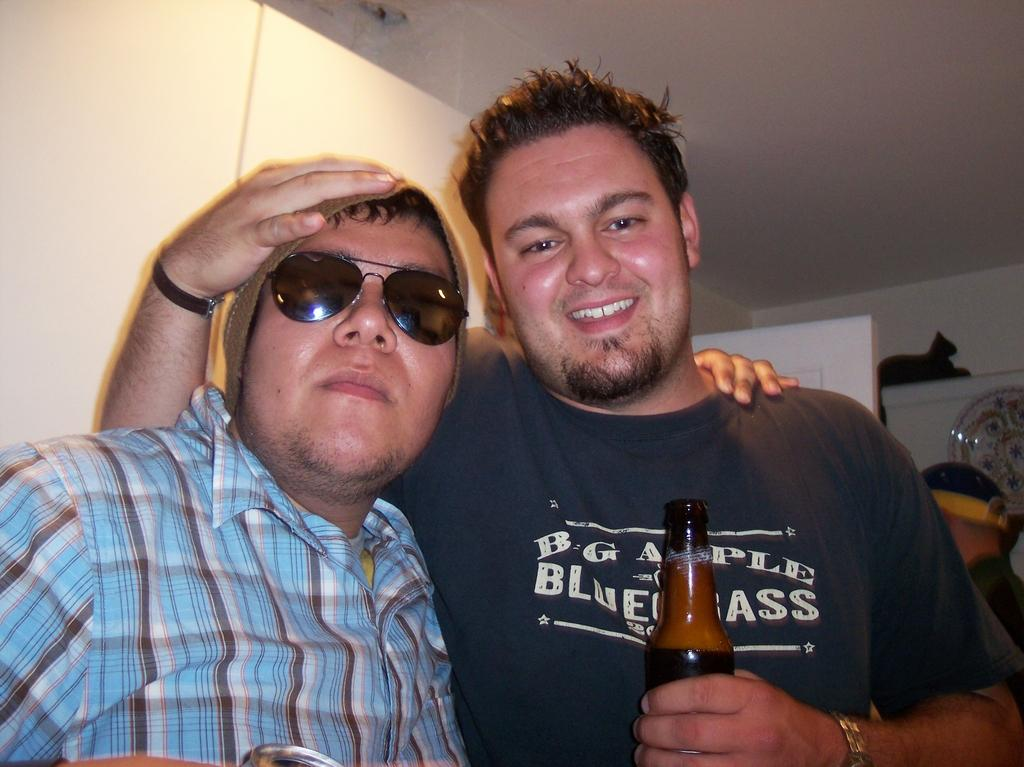How many people are in the image? There are two persons in the image. Can you describe the gender of one of the persons? One of the persons is a man. Where is the man located in the image? The man is on the right side of the image. What is the man holding in his left hand? The man is holding a bottle in his left hand. What is the man doing with his right hand? The man has his right hand on the head of the other person. What is the name of the street where the scene in the image takes place? There is no information about a street in the image, so it cannot be determined. 